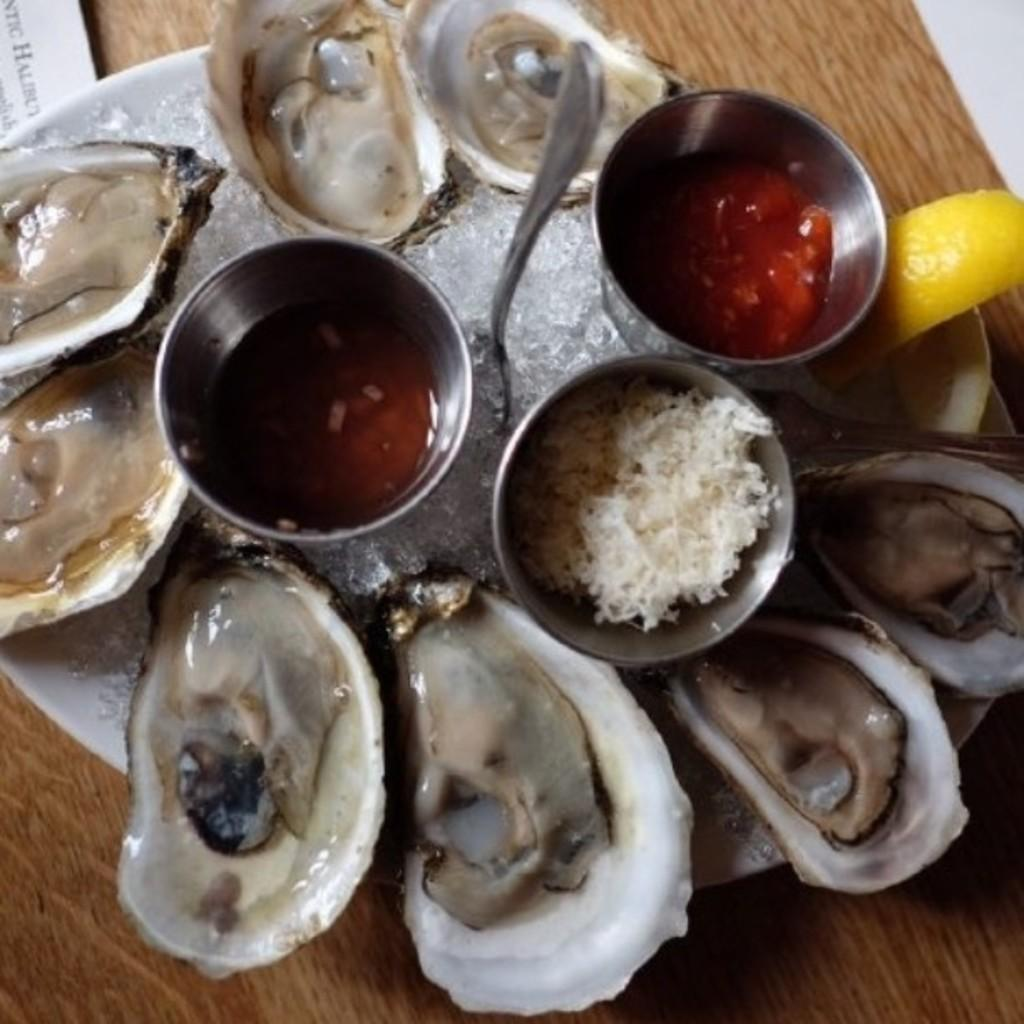What is the main object in the center of the image? There is a table in the center of the image. What can be seen on top of the table? Papers, a plate, a spoon, bowls, and food items are present on the table. Can you describe the utensils on the table? A spoon is visible on the table. What type of dishware is present on the table? Bowls are on the table. What type of horn can be seen on the table in the image? There is no horn present on the table in the image. What type of earth is visible in the image? The image does not depict any earth or soil; it is focused on objects on a table. 